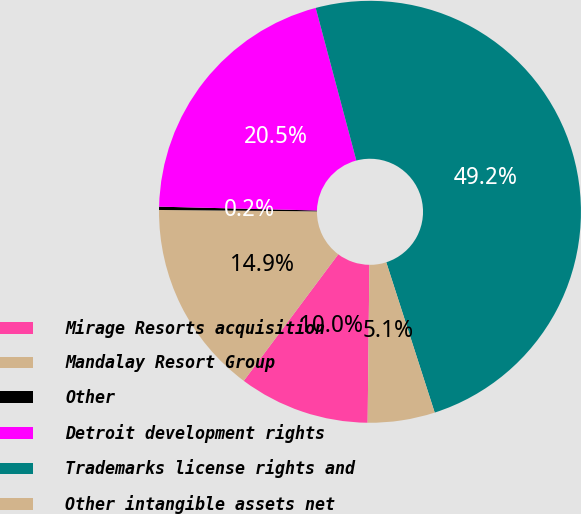<chart> <loc_0><loc_0><loc_500><loc_500><pie_chart><fcel>Mirage Resorts acquisition<fcel>Mandalay Resort Group<fcel>Other<fcel>Detroit development rights<fcel>Trademarks license rights and<fcel>Other intangible assets net<nl><fcel>10.03%<fcel>14.93%<fcel>0.25%<fcel>20.47%<fcel>49.18%<fcel>5.14%<nl></chart> 